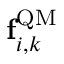Convert formula to latex. <formula><loc_0><loc_0><loc_500><loc_500>{ f } _ { i , k } ^ { Q M }</formula> 